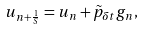<formula> <loc_0><loc_0><loc_500><loc_500>u _ { n + \frac { 1 } { S } } = u _ { n } + \tilde { p } _ { \delta t } g _ { n } ,</formula> 